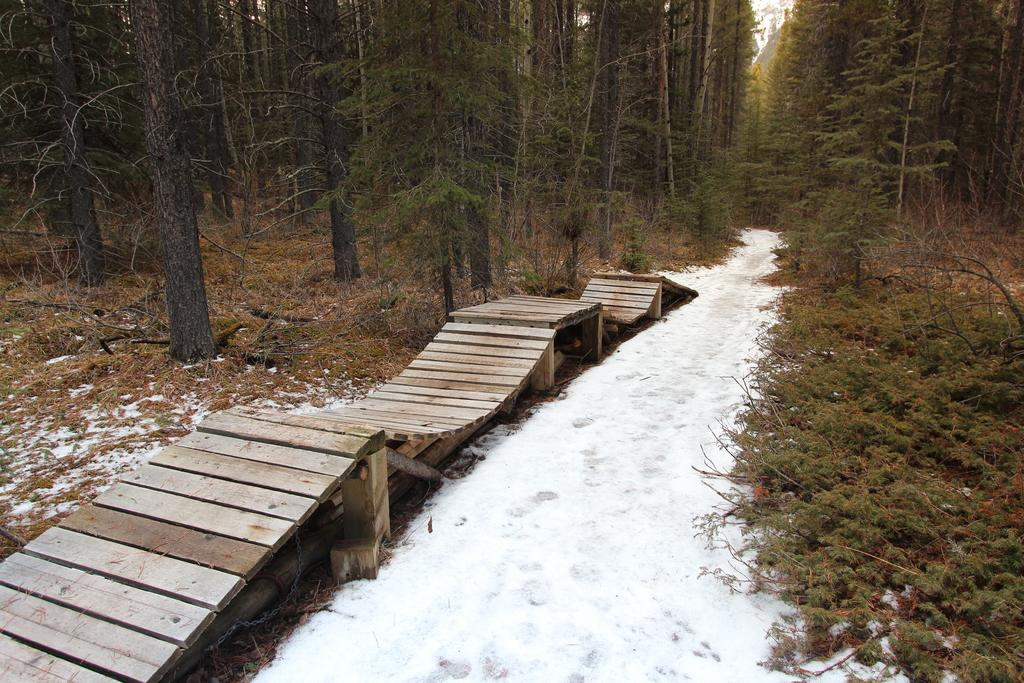What type of path is present in the image? There is a wooden path in the image. What is the ground covered with in the image? There is snow visible in the image. What type of vegetation can be seen in the image? There are trees in the image. What can be seen in the background of the image? The sky is visible in the background of the image. What type of magic is being performed on the wooden path in the image? There is no magic being performed in the image; it is a natural scene with a wooden path, snow, trees, and sky. 